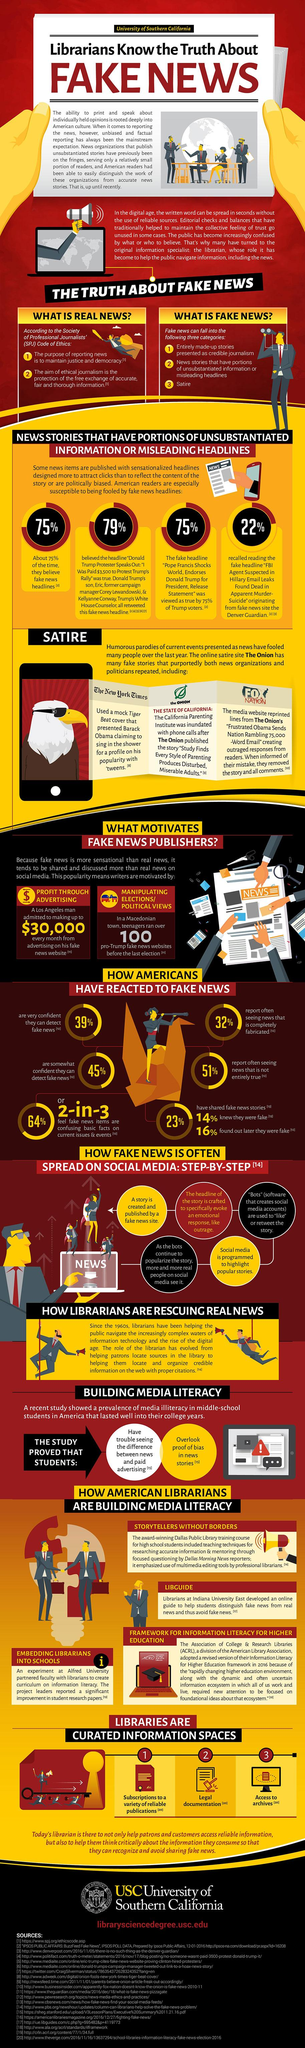List a handful of essential elements in this visual. According to a recent survey, 25% of Americans are not very confident in their ability to detect fake news. 